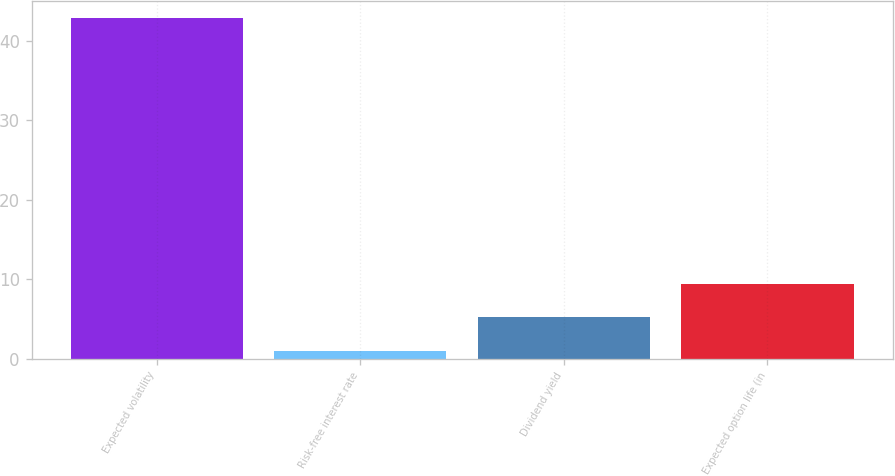<chart> <loc_0><loc_0><loc_500><loc_500><bar_chart><fcel>Expected volatility<fcel>Risk-free interest rate<fcel>Dividend yield<fcel>Expected option life (in<nl><fcel>42.93<fcel>0.98<fcel>5.18<fcel>9.38<nl></chart> 